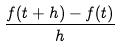Convert formula to latex. <formula><loc_0><loc_0><loc_500><loc_500>\frac { f ( t + h ) - f ( t ) } { h }</formula> 